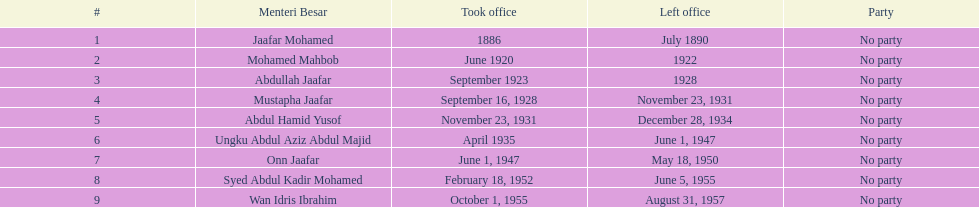Who was in power prior to abdullah jaafar? Mohamed Mahbob. 